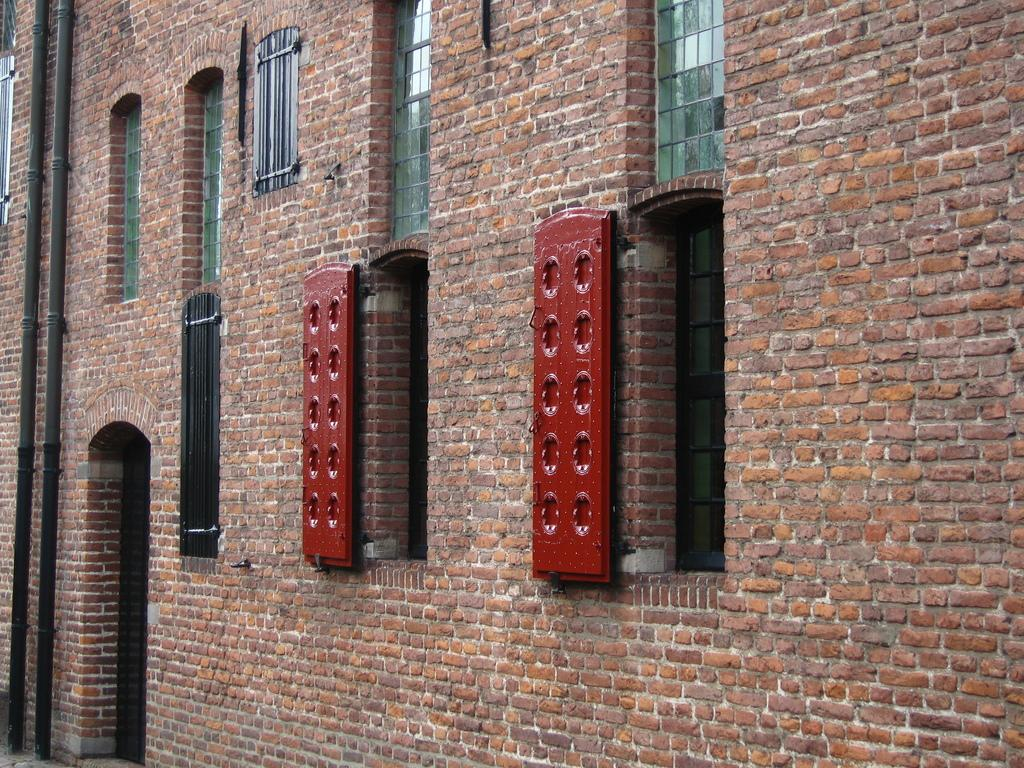What is the main structure in the center of the image? There is a building in the center of the image. What type of material is used for the wall in the image? There is a brick wall in the image. What type of windows can be seen in the building? There are glass windows in the image. How many red objects are present in the image? There are two red color objects in the image. What type of infrastructure is visible in the image? Pipes are present in the image. What type of journey are the girls taking with the governor in the image? There are no girls or governor present in the image; it only features a building, a brick wall, glass windows, two red objects, and pipes. 